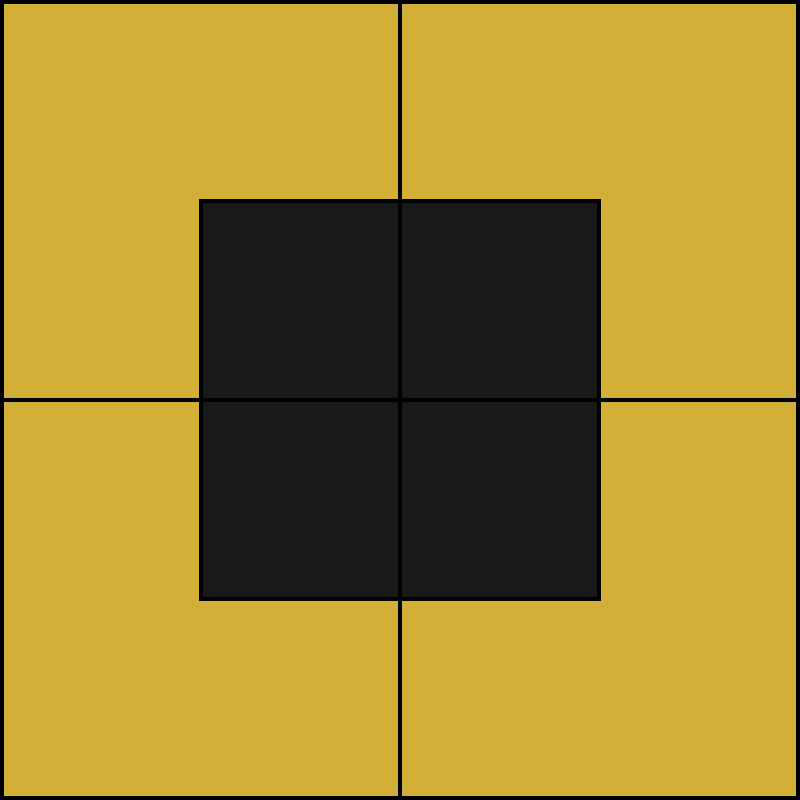In this Art Deco-inspired geometric pattern reminiscent of 1920s French cinema set design, what is the ratio of the area of the black square to the total area of the golden background? Let's approach this step-by-step:

1. The entire square represents the total area. Let's assume its side length is 4 units.

2. The area of the entire square (golden background) is:
   $$A_{total} = 4^2 = 16$$ square units

3. The black square is positioned in the center. Its side length is half of the total square's side length:
   $$\text{Side of black square} = 4 \div 2 = 2$$ units

4. The area of the black square is:
   $$A_{black} = 2^2 = 4$$ square units

5. To find the ratio, we divide the area of the black square by the total area:
   $$\text{Ratio} = \frac{A_{black}}{A_{total}} = \frac{4}{16} = \frac{1}{4}$$

6. This can be expressed as 1:4 or 0.25 or 25%.
Answer: 1:4 